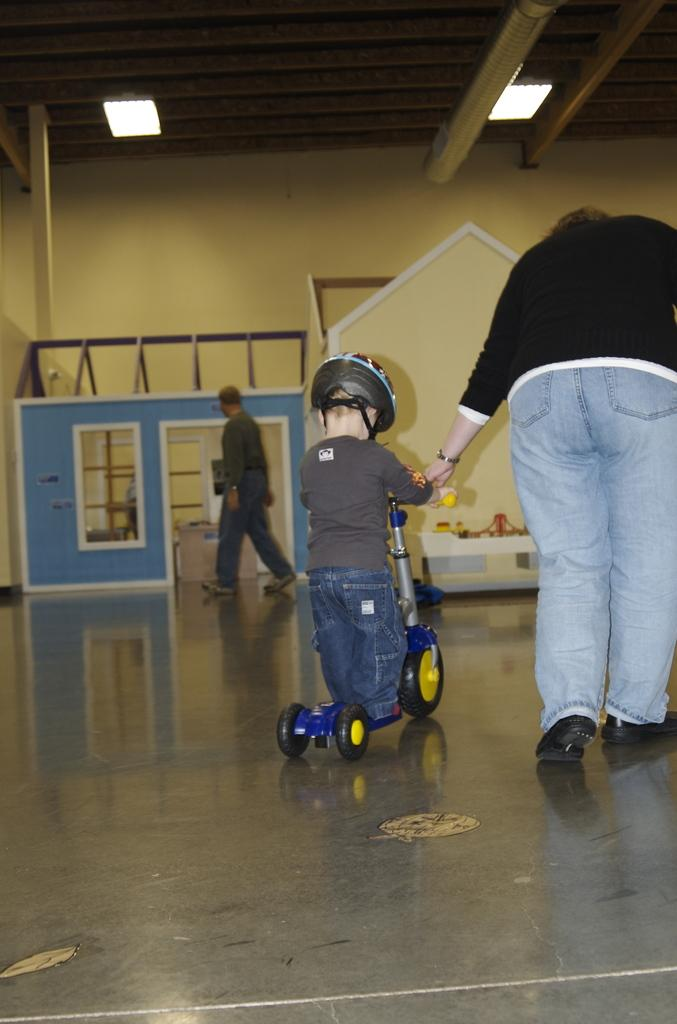How many people are in the image? There are three persons in the image. What is the kid doing in the image? The kid is riding a skate scooter. What safety precaution is the kid taking while riding the skate scooter? The kid is wearing a helmet. What type of structures can be seen in the image? There are huts in the image. What type of illumination is present in the image? There are lights in the image. What architectural elements can be seen in the image? There is a wall and a roof in the image. What month is it in the image? The month cannot be determined from the image, as there are no indications of the time of year. Can you tell me how many clams are present in the image? There are no clams visible in the image. What type of metal is used for the roof in the image? The type of metal used for the roof cannot be determined from the image, as there is no information about the material used. 